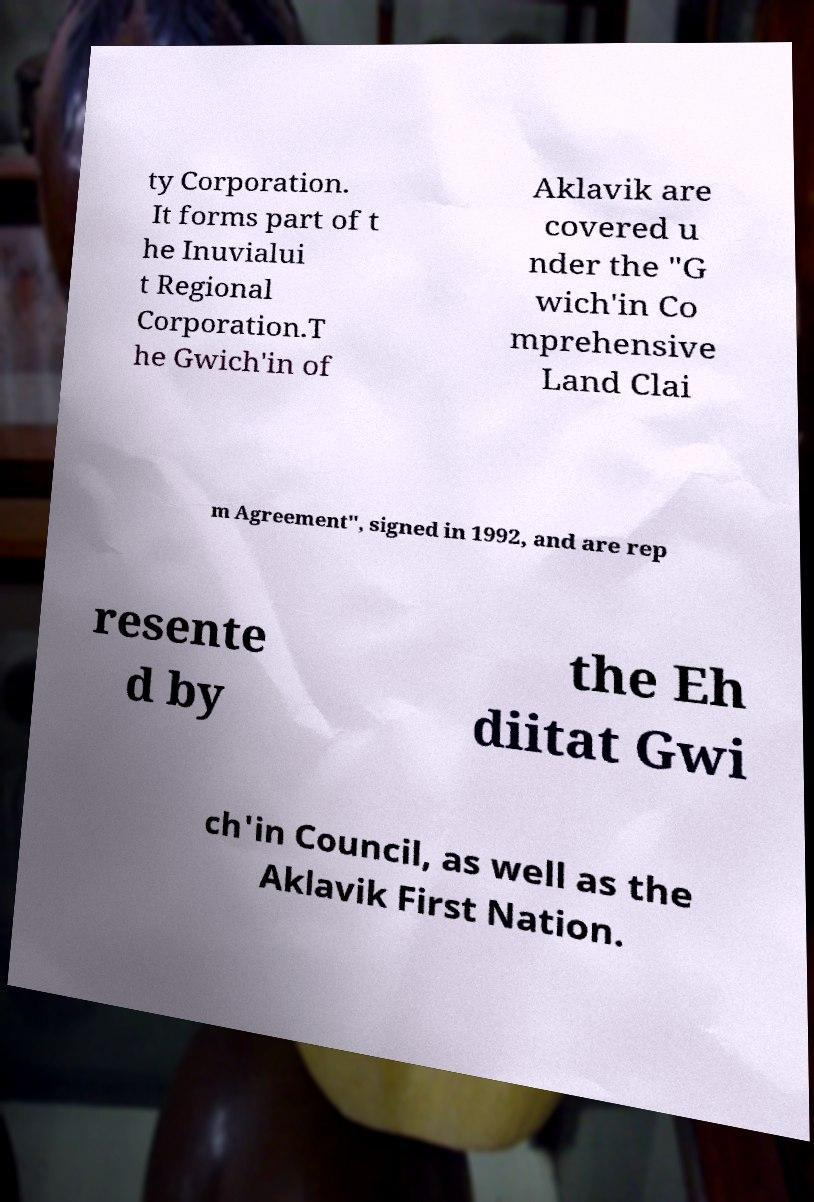Please identify and transcribe the text found in this image. ty Corporation. It forms part of t he Inuvialui t Regional Corporation.T he Gwich'in of Aklavik are covered u nder the "G wich'in Co mprehensive Land Clai m Agreement", signed in 1992, and are rep resente d by the Eh diitat Gwi ch'in Council, as well as the Aklavik First Nation. 